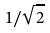<formula> <loc_0><loc_0><loc_500><loc_500>1 / \sqrt { 2 }</formula> 